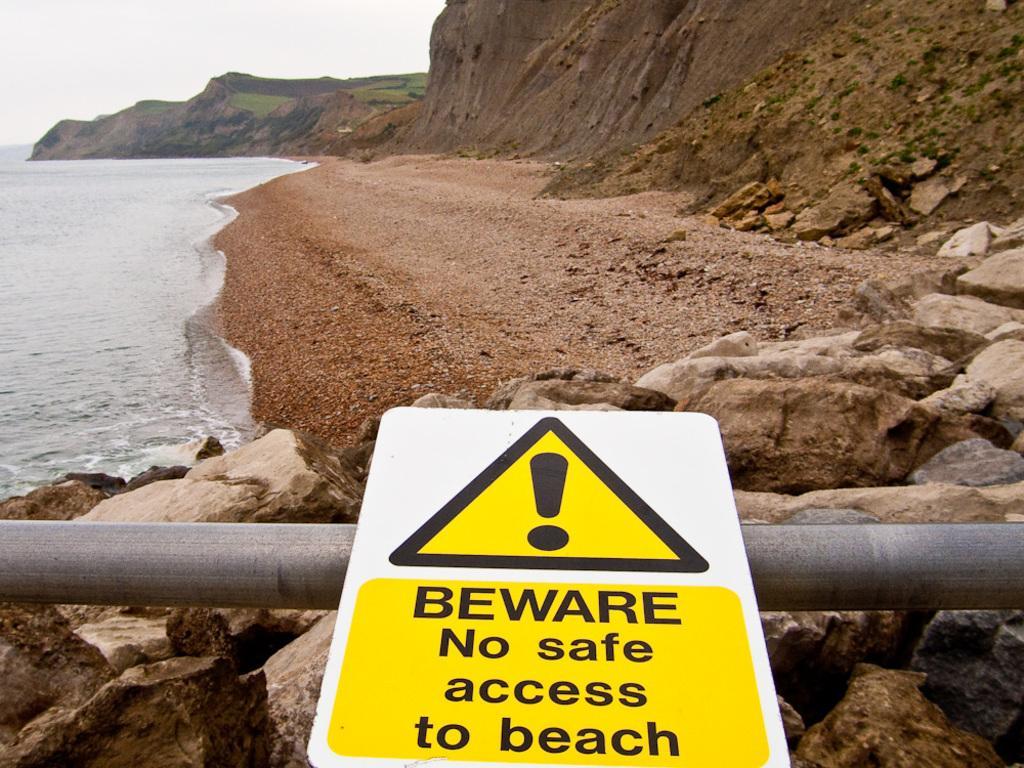In one or two sentences, can you explain what this image depicts? In this image there is a sign board with some text on it, beneath the board there is a rod on the surface of the rocks and in the background there is a river and the sky. 